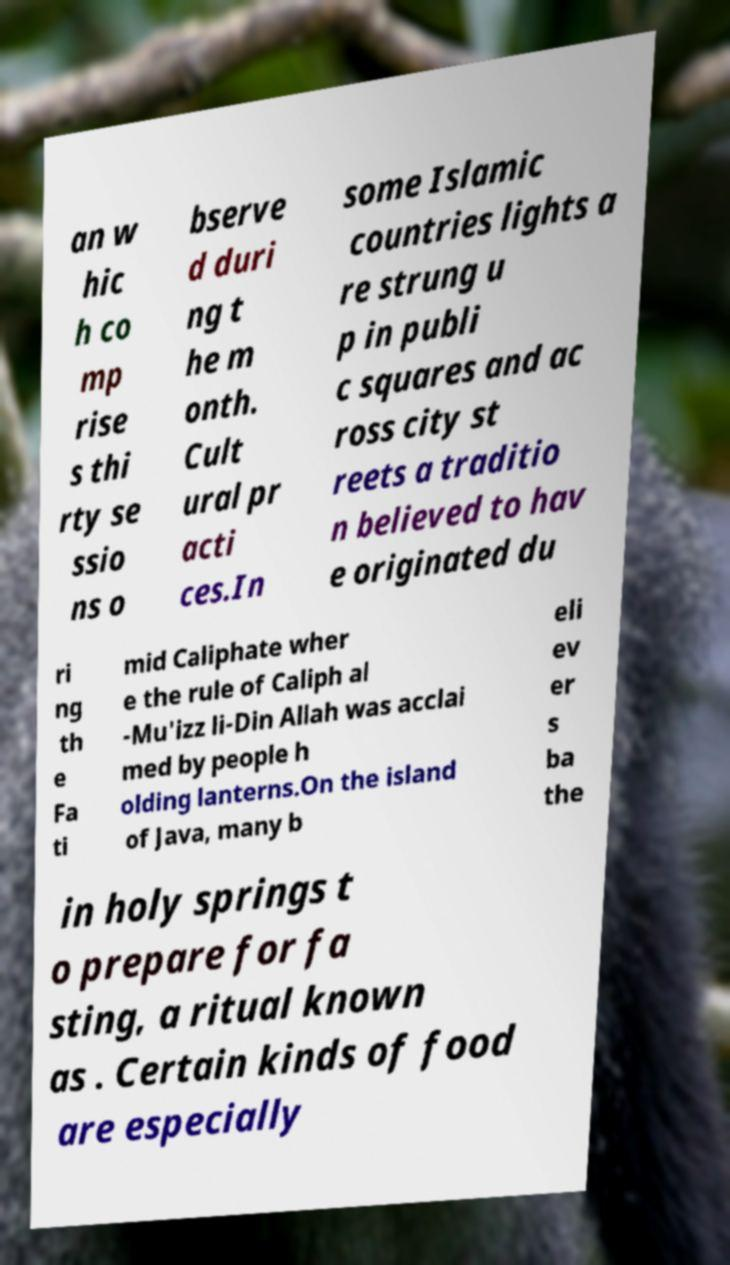Could you extract and type out the text from this image? an w hic h co mp rise s thi rty se ssio ns o bserve d duri ng t he m onth. Cult ural pr acti ces.In some Islamic countries lights a re strung u p in publi c squares and ac ross city st reets a traditio n believed to hav e originated du ri ng th e Fa ti mid Caliphate wher e the rule of Caliph al -Mu'izz li-Din Allah was acclai med by people h olding lanterns.On the island of Java, many b eli ev er s ba the in holy springs t o prepare for fa sting, a ritual known as . Certain kinds of food are especially 